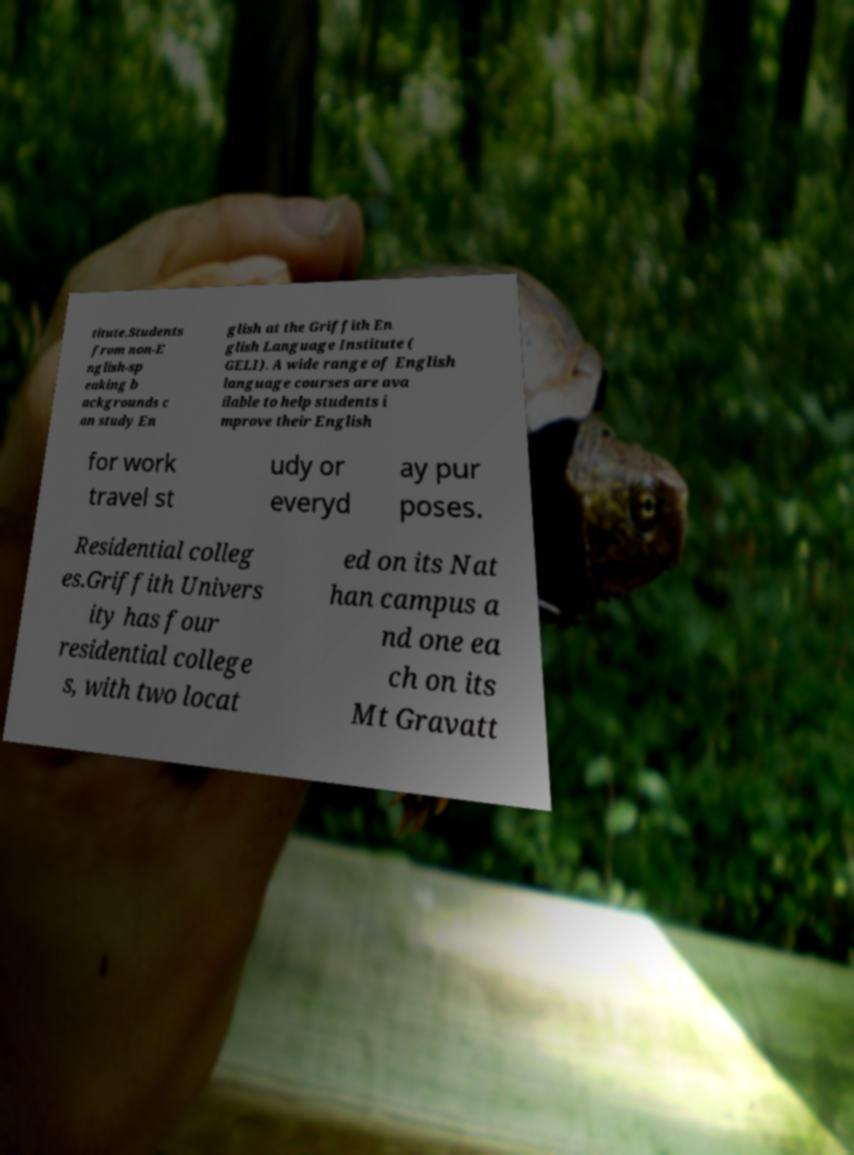Can you read and provide the text displayed in the image?This photo seems to have some interesting text. Can you extract and type it out for me? titute.Students from non-E nglish-sp eaking b ackgrounds c an study En glish at the Griffith En glish Language Institute ( GELI). A wide range of English language courses are ava ilable to help students i mprove their English for work travel st udy or everyd ay pur poses. Residential colleg es.Griffith Univers ity has four residential college s, with two locat ed on its Nat han campus a nd one ea ch on its Mt Gravatt 